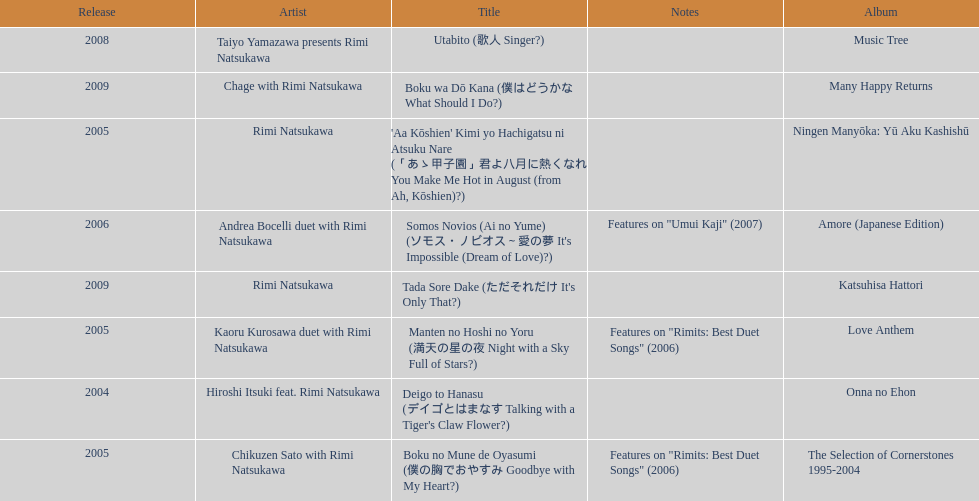What has been the last song this artist has made an other appearance on? Tada Sore Dake. 